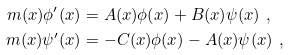<formula> <loc_0><loc_0><loc_500><loc_500>m ( x ) \phi ^ { \prime } ( x ) & = A ( x ) \phi ( x ) + B ( x ) \psi ( x ) \ , \\ m ( x ) \psi ^ { \prime } ( x ) & = - C ( x ) \phi ( x ) - A ( x ) \psi ( x ) \ ,</formula> 